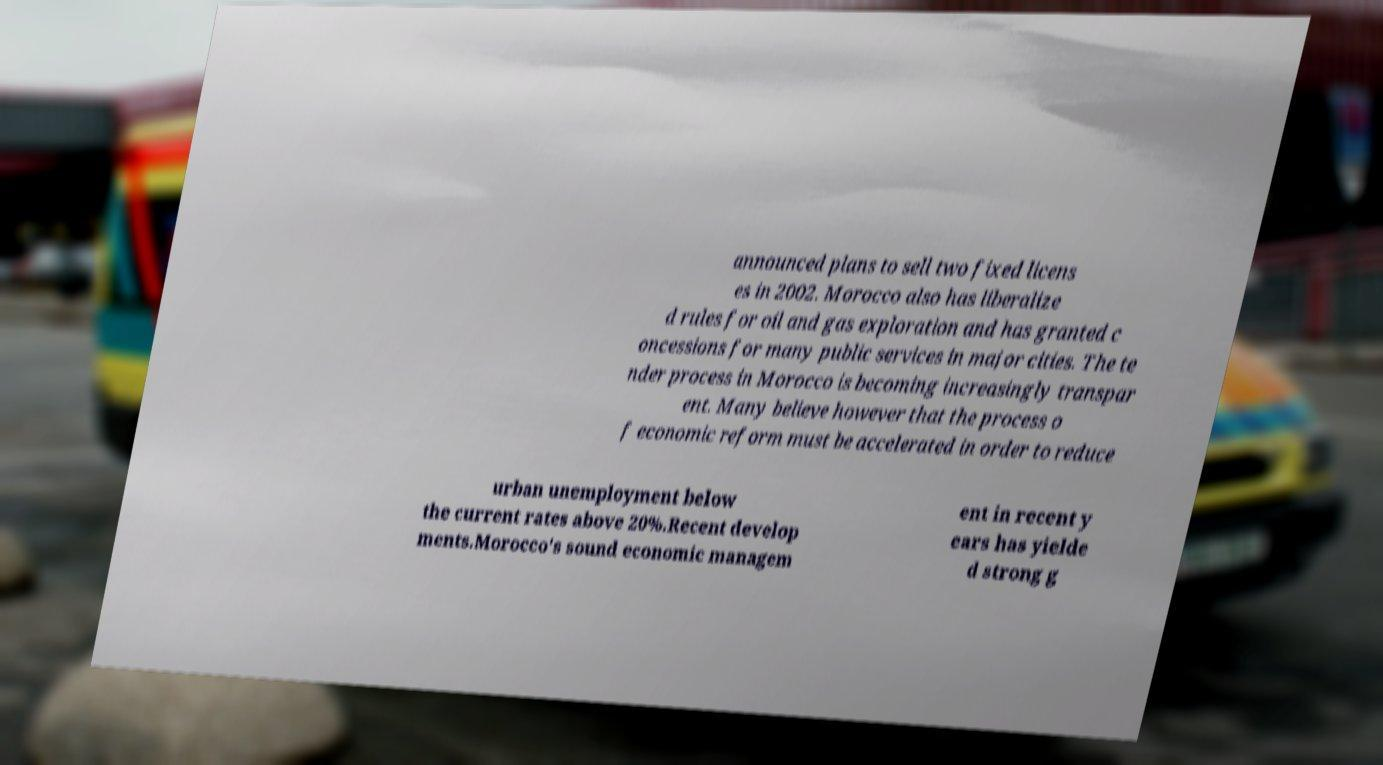What messages or text are displayed in this image? I need them in a readable, typed format. announced plans to sell two fixed licens es in 2002. Morocco also has liberalize d rules for oil and gas exploration and has granted c oncessions for many public services in major cities. The te nder process in Morocco is becoming increasingly transpar ent. Many believe however that the process o f economic reform must be accelerated in order to reduce urban unemployment below the current rates above 20%.Recent develop ments.Morocco's sound economic managem ent in recent y ears has yielde d strong g 